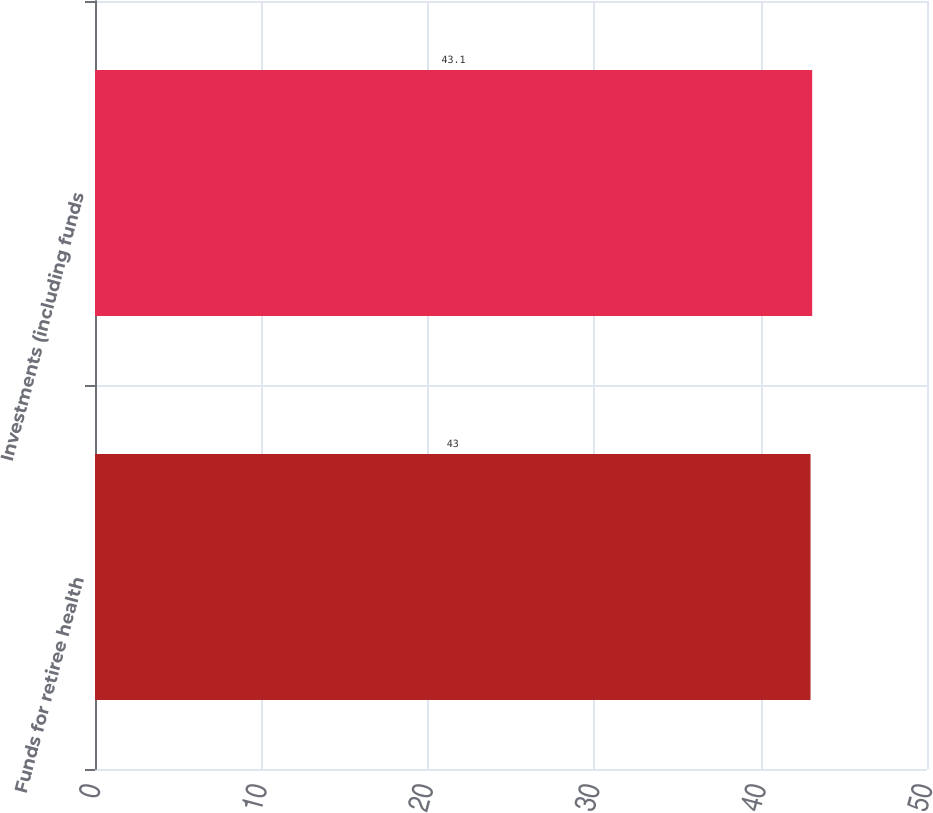<chart> <loc_0><loc_0><loc_500><loc_500><bar_chart><fcel>Funds for retiree health<fcel>Investments (including funds<nl><fcel>43<fcel>43.1<nl></chart> 